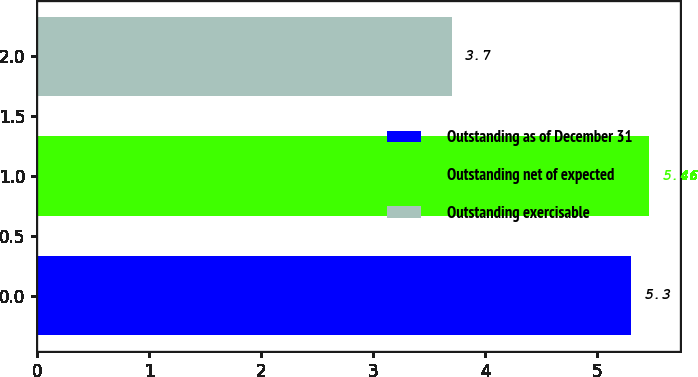<chart> <loc_0><loc_0><loc_500><loc_500><bar_chart><fcel>Outstanding as of December 31<fcel>Outstanding net of expected<fcel>Outstanding exercisable<nl><fcel>5.3<fcel>5.46<fcel>3.7<nl></chart> 